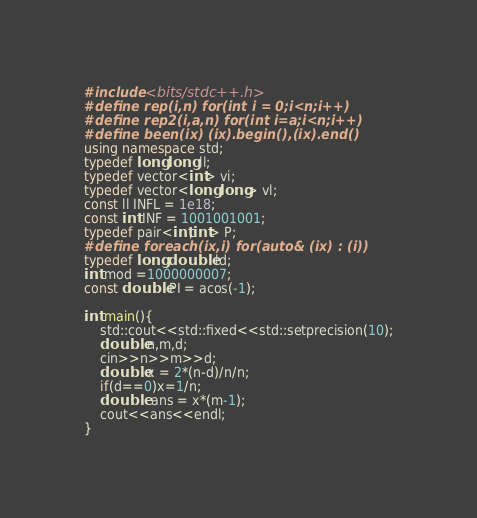<code> <loc_0><loc_0><loc_500><loc_500><_C++_>#include <bits/stdc++.h>
#define rep(i,n) for(int i = 0;i<n;i++)
#define rep2(i,a,n) for(int i=a;i<n;i++)
#define been(ix) (ix).begin(),(ix).end()
using namespace std;
typedef long long ll; 
typedef vector<int> vi;
typedef vector<long long> vl;
const ll INFL = 1e18;
const int INF = 1001001001; 
typedef pair<int,int> P;
#define foreach(ix,i) for(auto& (ix) : (i))
typedef long double ld;
int mod =1000000007;
const double PI = acos(-1);

int main(){
    std::cout<<std::fixed<<std::setprecision(10);
    double n,m,d;
    cin>>n>>m>>d;
    double x = 2*(n-d)/n/n;
    if(d==0)x=1/n;
    double  ans = x*(m-1);
    cout<<ans<<endl;
}</code> 